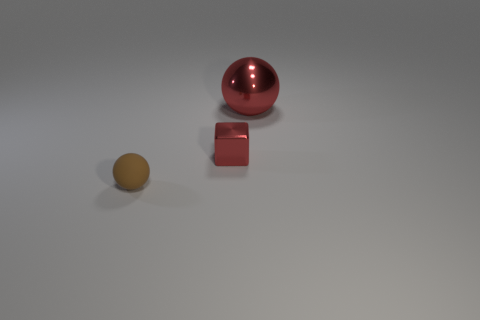What shape is the red shiny object behind the tiny object that is right of the tiny brown rubber thing that is left of the big red shiny ball?
Make the answer very short. Sphere. The thing that is the same size as the matte sphere is what color?
Your answer should be very brief. Red. How many big red shiny objects are the same shape as the brown object?
Offer a very short reply. 1. There is a brown matte ball; is its size the same as the ball that is right of the matte object?
Provide a succinct answer. No. The shiny object on the right side of the small thing behind the brown thing is what shape?
Provide a succinct answer. Sphere. Is the number of brown things behind the tiny rubber sphere less than the number of big red metallic objects?
Make the answer very short. Yes. There is a tiny object that is the same color as the metal ball; what shape is it?
Provide a short and direct response. Cube. How many other red spheres are the same size as the red sphere?
Keep it short and to the point. 0. The red object that is to the left of the large red ball has what shape?
Offer a terse response. Cube. Is the number of tiny rubber spheres less than the number of cylinders?
Your response must be concise. No. 